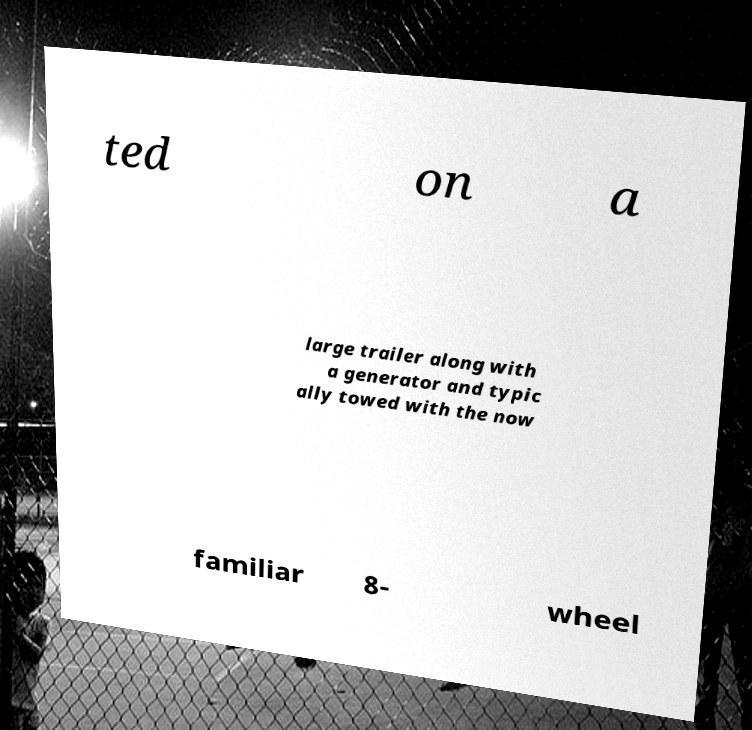Can you accurately transcribe the text from the provided image for me? ted on a large trailer along with a generator and typic ally towed with the now familiar 8- wheel 